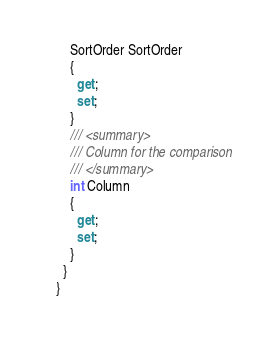Convert code to text. <code><loc_0><loc_0><loc_500><loc_500><_C#_>    SortOrder SortOrder
    {
      get;
      set;
    }
    /// <summary>
    /// Column for the comparison
    /// </summary>
    int Column
    {
      get;
      set;
    }
  }
}
</code> 